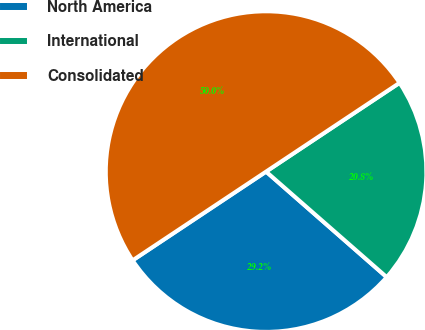<chart> <loc_0><loc_0><loc_500><loc_500><pie_chart><fcel>North America<fcel>International<fcel>Consolidated<nl><fcel>29.22%<fcel>20.78%<fcel>50.0%<nl></chart> 